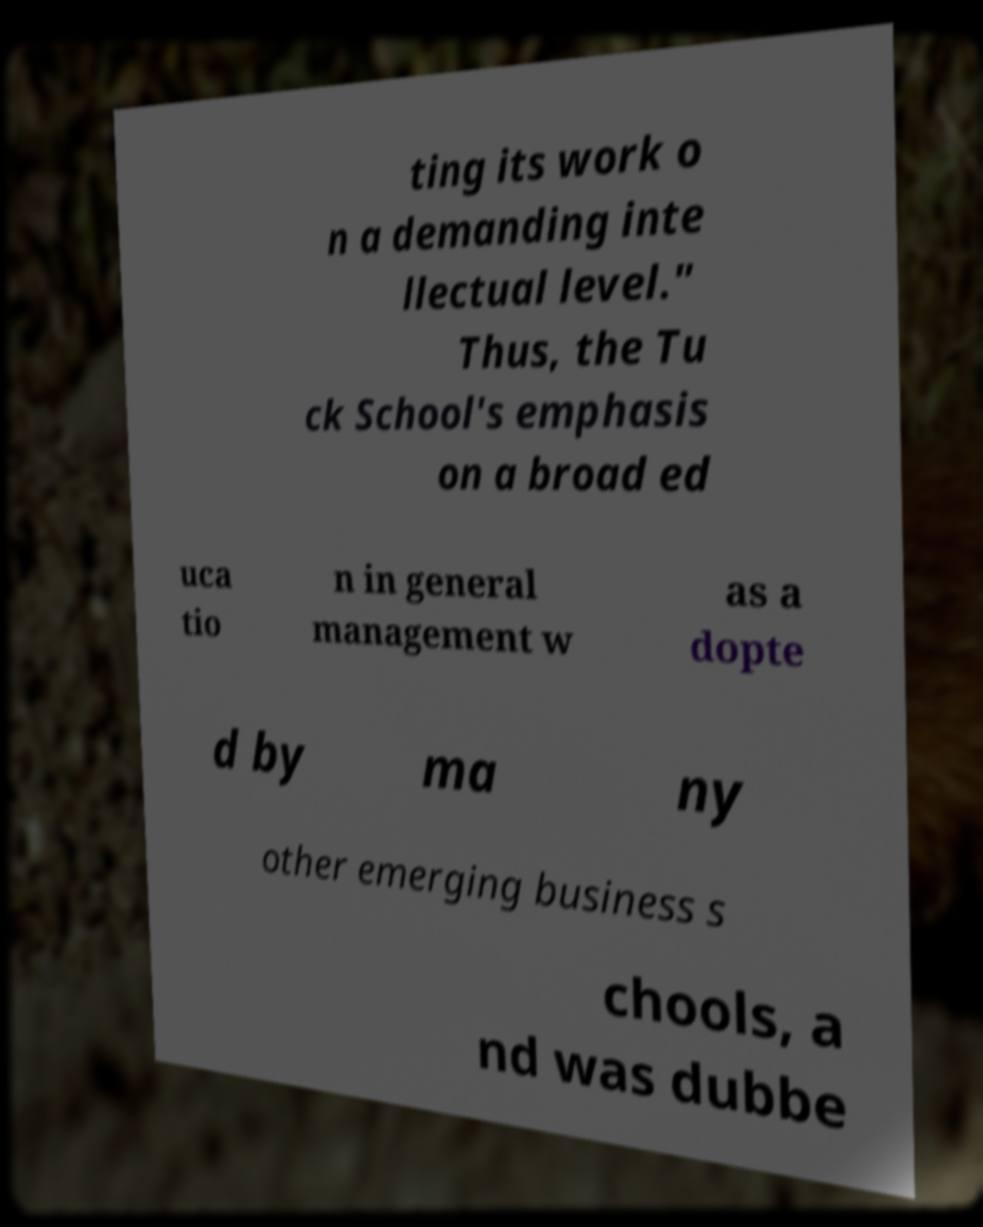What messages or text are displayed in this image? I need them in a readable, typed format. ting its work o n a demanding inte llectual level." Thus, the Tu ck School's emphasis on a broad ed uca tio n in general management w as a dopte d by ma ny other emerging business s chools, a nd was dubbe 